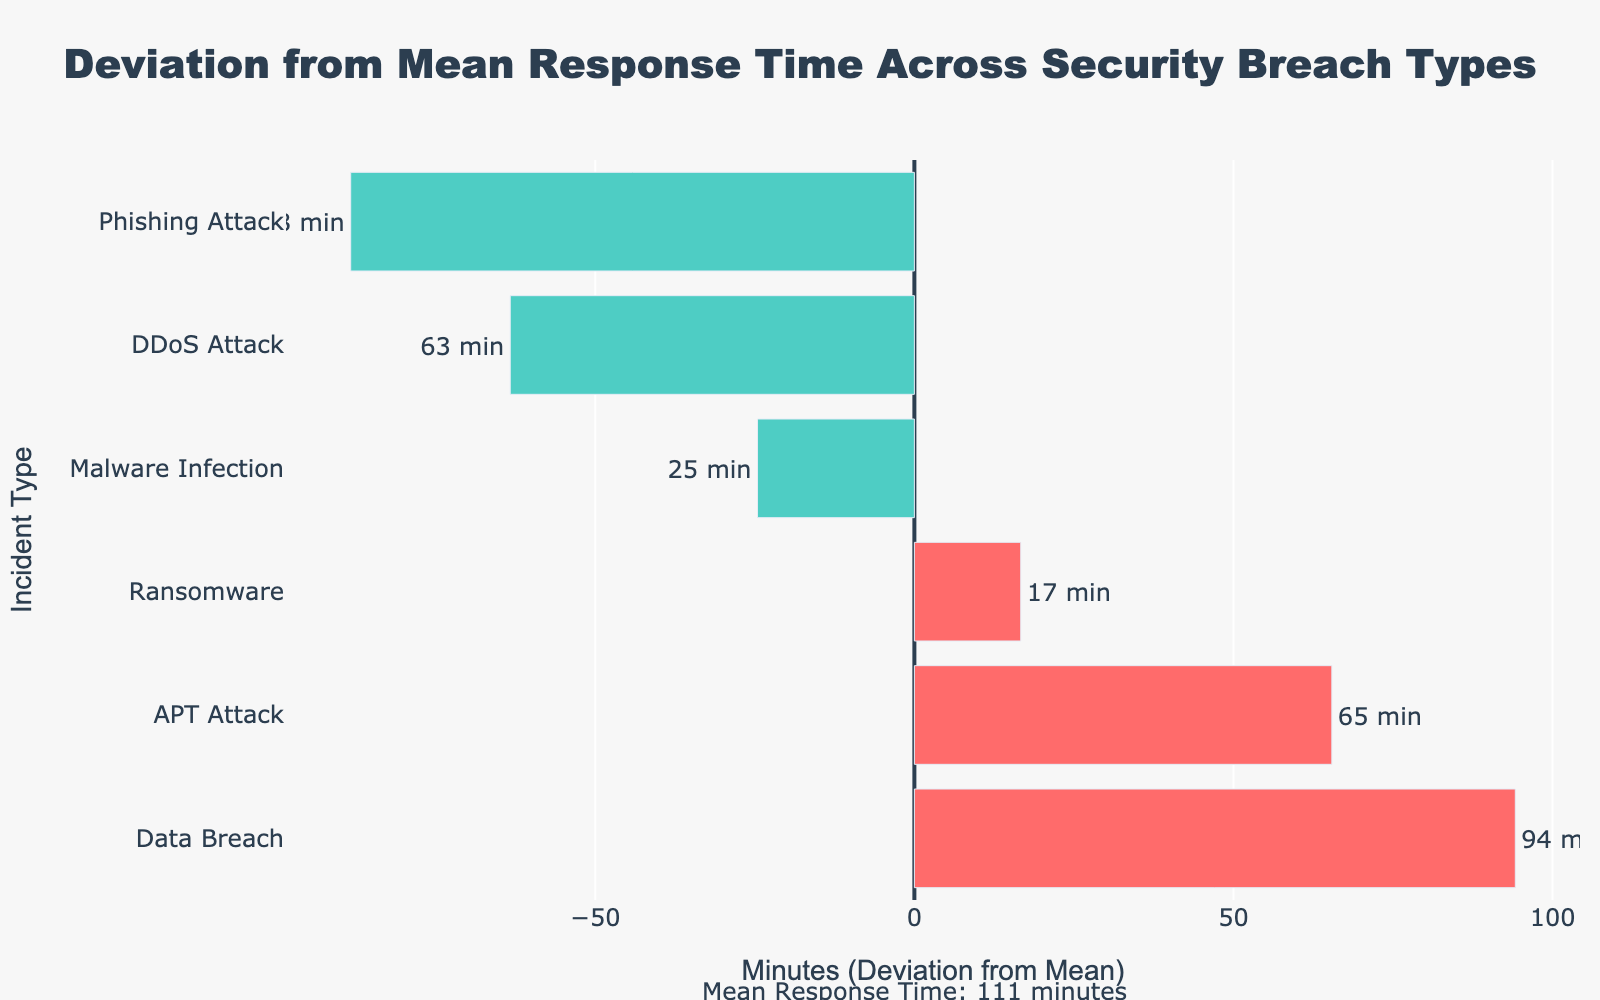What is the mean response time for data breach incidents? The figure does not directly provide the mean response time for each incident type, but it shows deviations from the overall mean. Since Data Breach has a bar of +85 minutes and the mean response time is given as 90 minutes in the annotation, you can calculate it. The mean response time for Data Breach is 85 + 90 = 175 minutes.
Answer: 175 minutes Which incident type has the fastest response time on average? The figure shows deviations from the mean response time, with bars either extending to the left or the right. The incident type with the most negative deviation indicates the fastest response time. Phishing Attack has the largest deviation to the left.
Answer: Phishing Attack How much faster, on average, is the response to phishing attacks compared to ransomware attacks? To find this, we need the deviations from the mean for both incident types. Phishing Attack is -52 minutes and Ransomware is +52.5 minutes. The difference between them is 52 + 52.5 = 104.5 minutes.
Answer: 104.5 minutes Which incident type has the most positive deviation from the mean response time? The figure shows bars extending to the right as positive deviations. Data Breach has the most positive deviation from the mean response time.
Answer: Data Breach By how many minutes does the average response time to APT attacks deviate from the mean response time? According to the figure, the deviation for APT Attack is +47.5 minutes. This value represents how much the average response time for APT attacks deviates from the mean response time.
Answer: 47.5 minutes Rank the incident types from fastest to slowest average response time. From the figure, we can rank the incident types by their deviations from the mean. Negative deviations indicate faster response times, and positive deviations indicate slower response times. The ranking from fastest to slowest is: 1) Phishing Attack (-52 min), 2) DDoS Attack (-30 min), 3) Malware Infection (-4 min), 4) APT Attack (+47.5 min), 5) Ransomware (+52.5 min), 6) Data Breach (+85 min).
Answer: Phishing Attack, DDoS Attack, Malware Infection, APT Attack, Ransomware, Data Breach 